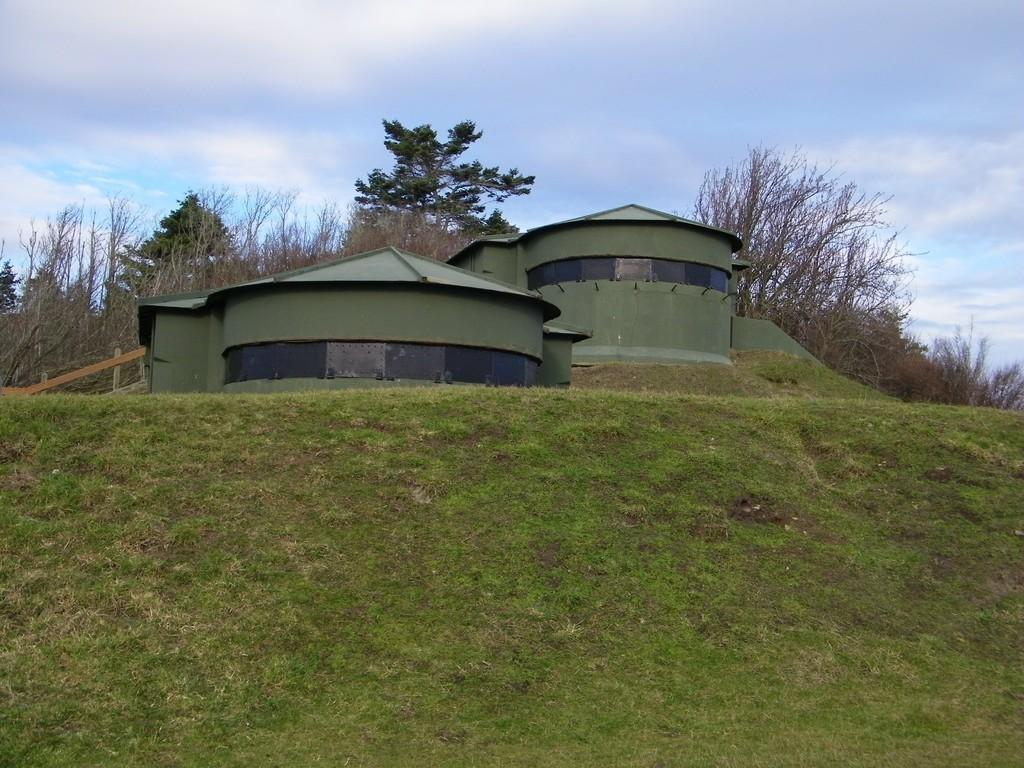What type of structures can be seen in the image? There are houses in the image. What natural elements are present in the image? There are many trees and plants in the image. What is the ground made of in the image? There is a grassy land in the image. What can be seen in the sky in the image? The sky is visible in the image, and there are clouds in the sky. Where is the coal mine located in the image? There is no coal mine present in the image. What season is depicted in the image? The provided facts do not mention a specific season, so it cannot be definitively answered from the image. 